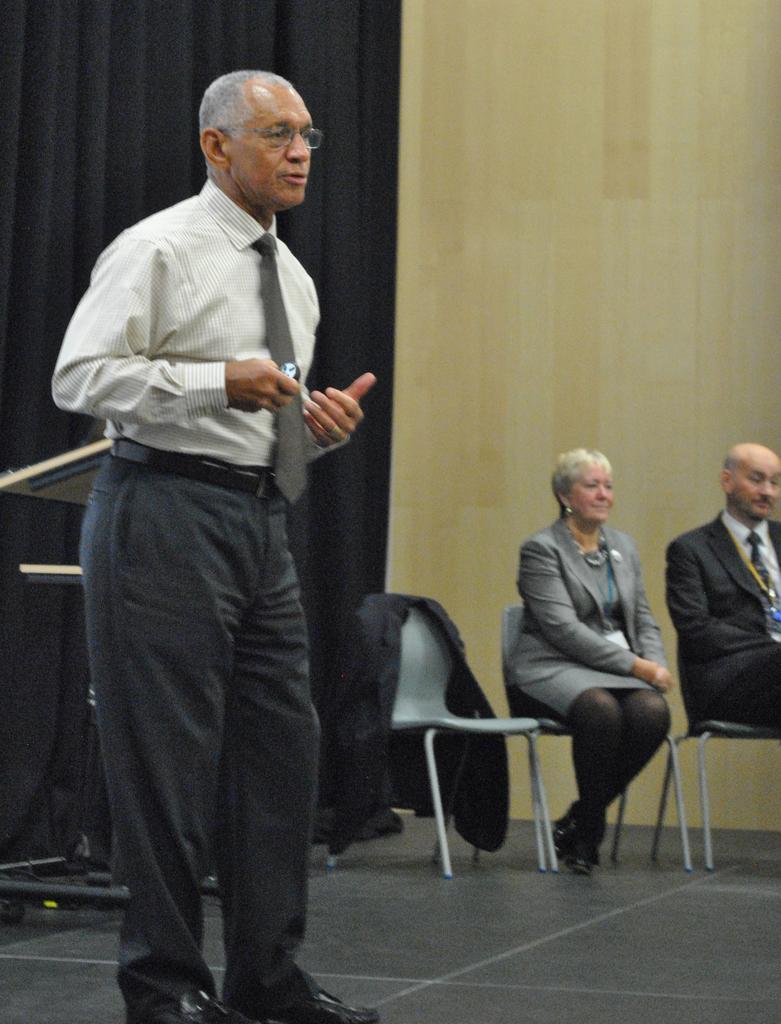Describe this image in one or two sentences. In this image I can see a person standing. 2 people are seated. There are black curtains at the back. There is a stand on the left. 